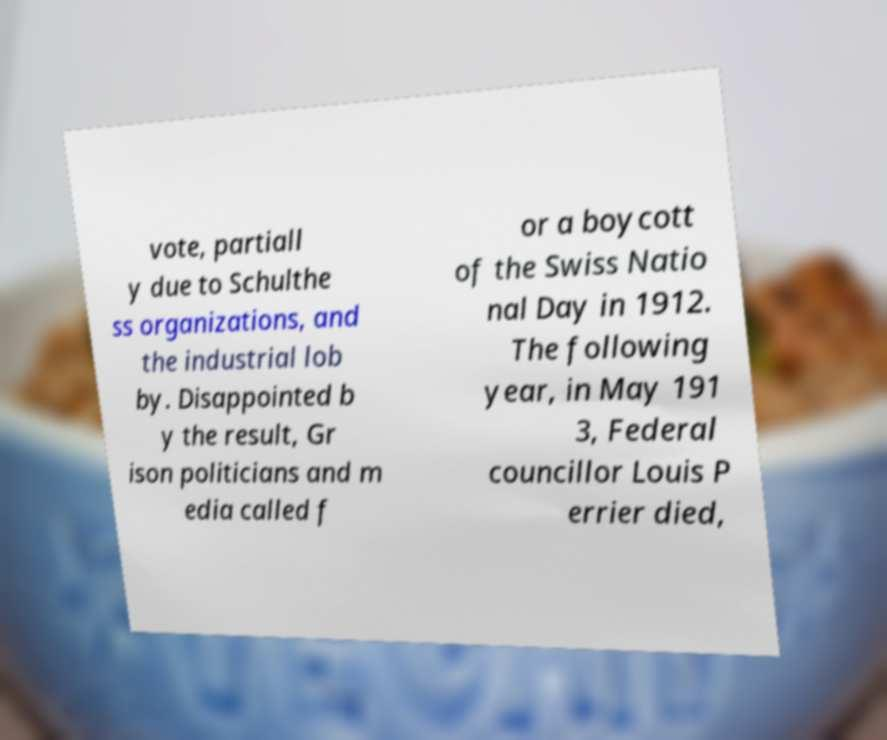There's text embedded in this image that I need extracted. Can you transcribe it verbatim? vote, partiall y due to Schulthe ss organizations, and the industrial lob by. Disappointed b y the result, Gr ison politicians and m edia called f or a boycott of the Swiss Natio nal Day in 1912. The following year, in May 191 3, Federal councillor Louis P errier died, 